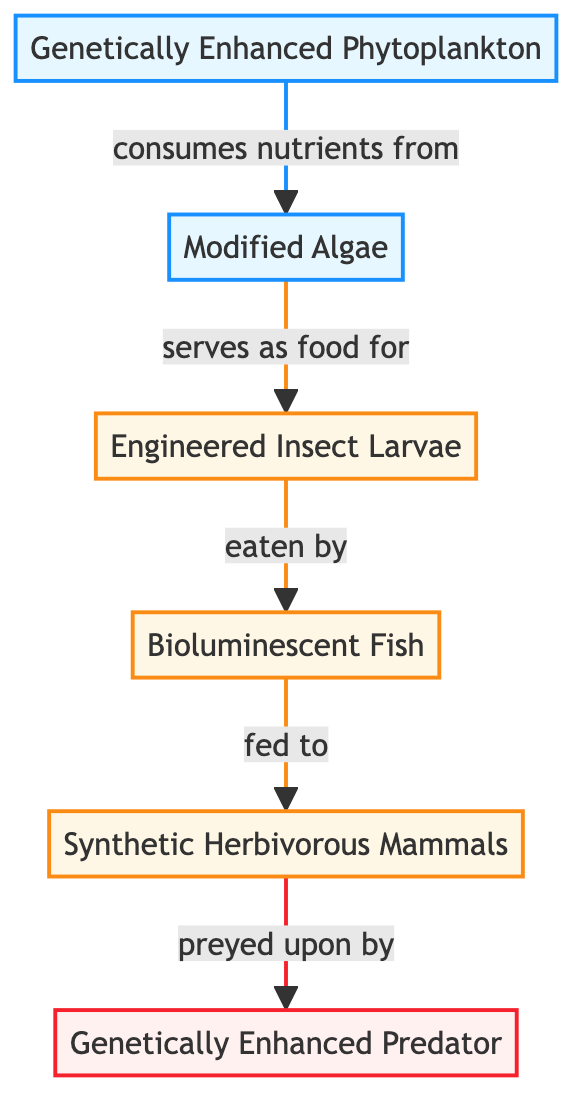What is the starting point of the food chain? In the diagram, the starting point is represented by the first node labeled "Genetically Enhanced Phytoplankton". This indicates that it is the initial producer in the food chain.
Answer: Genetically Enhanced Phytoplankton How many consumer nodes are in the diagram? By counting each node classified as a consumer, there are three consumer nodes: "Engineered Insect Larvae", "Bioluminescent Fish", and "Synthetic Herbivorous Mammals".
Answer: 3 Which producer is directly consumed by the Engineered Insect Larvae? The Engineered Insect Larvae are directly fed by the Modified Algae, indicated by the arrow connecting these nodes.
Answer: Modified Algae Who is the ultimate predator in this synthetic ecosystem? The ultimate predator in the diagram is the "Genetically Enhanced Predator", which preys upon the synthetic herbivorous mammals.
Answer: Genetically Enhanced Predator What type of organism is the Bioluminescent Fish in the food chain? The Bioluminescent Fish is categorized as a consumer, which means it feeds on the Engineered Insect Larvae, making it part of the consumer trophic level.
Answer: Consumer What role do Genetically Enhanced Phytoplankton play in this ecosystem? Genetically Enhanced Phytoplankton serve as the primary producers, as they obtain nutrients from the Modified Algae and form the base of the food chain.
Answer: Producers Which node indicates a direct feeding relationship? The arrows in the diagram indicate direct feeding relationships; for example, the arrow from "Modified Algae" to "Engineered Insect Larvae" shows this relationship.
Answer: Modified Algae to Engineered Insect Larvae How many total nodes are represented in the diagram? The total count includes all nodes: 2 producers (Genetically Enhanced Phytoplankton and Modified Algae), 3 consumers (Engineered Insect Larvae, Bioluminescent Fish, and Synthetic Herbivorous Mammals), and 1 predator (Genetically Enhanced Predator), summing up to 6 nodes.
Answer: 6 What is the relationship between Bioluminescent Fish and Synthetic Herbivorous Mammals? The Bioluminescent Fish is part of the food chain where it is consumed by the Synthetic Herbivorous Mammals, indicating a sequential feeding relationship.
Answer: Consumed by Synthetic Herbivorous Mammals 